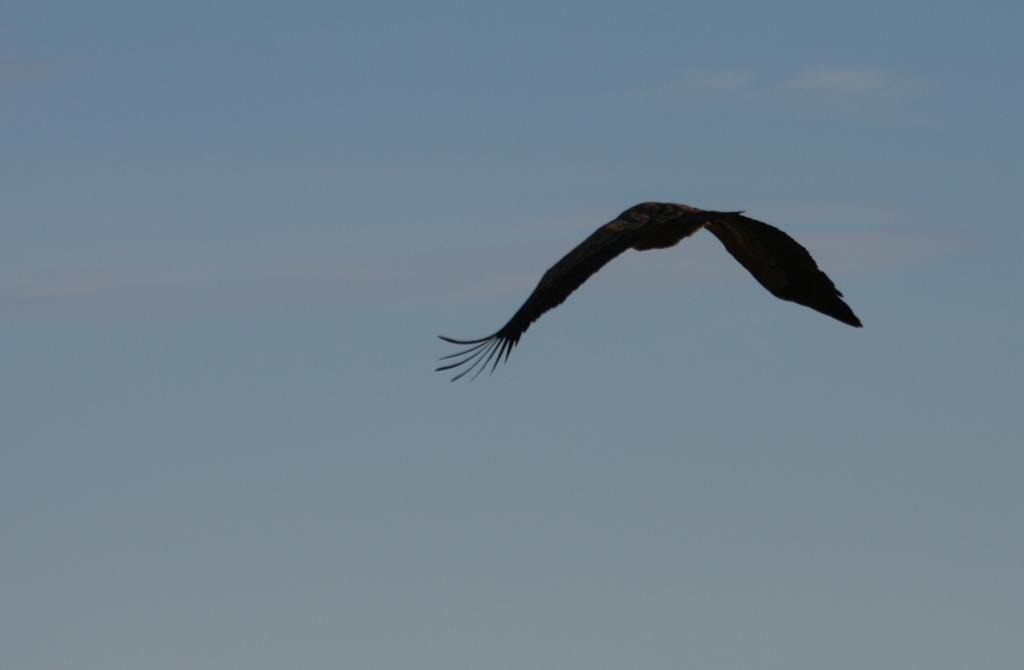What type of animal can be seen in the image? There is a bird in the image. What is the bird doing in the image? The bird is flying in the sky. On which side of the image is the bird located? The bird is on the right side of the image. Can you hear the bird singing in the image? There is no sound in the image, so it is not possible to hear the bird singing. 